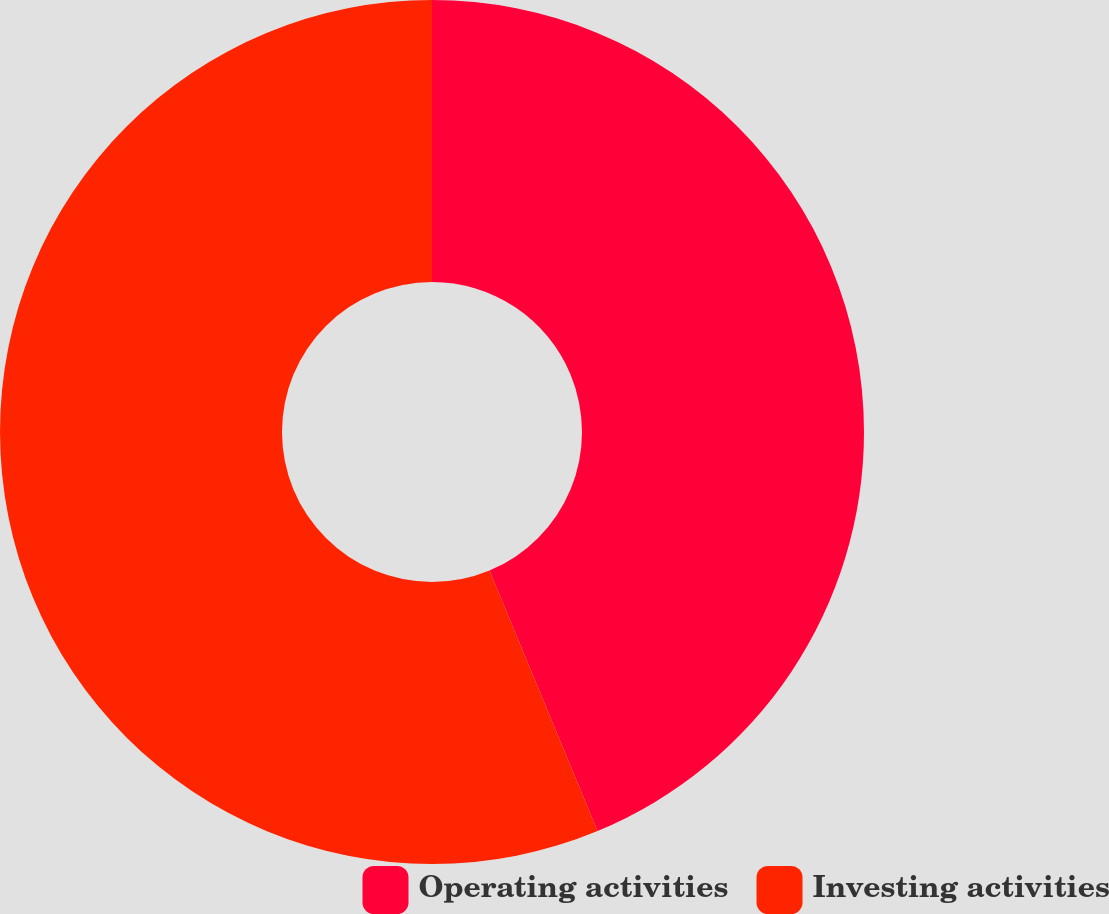Convert chart to OTSL. <chart><loc_0><loc_0><loc_500><loc_500><pie_chart><fcel>Operating activities<fcel>Investing activities<nl><fcel>43.74%<fcel>56.26%<nl></chart> 